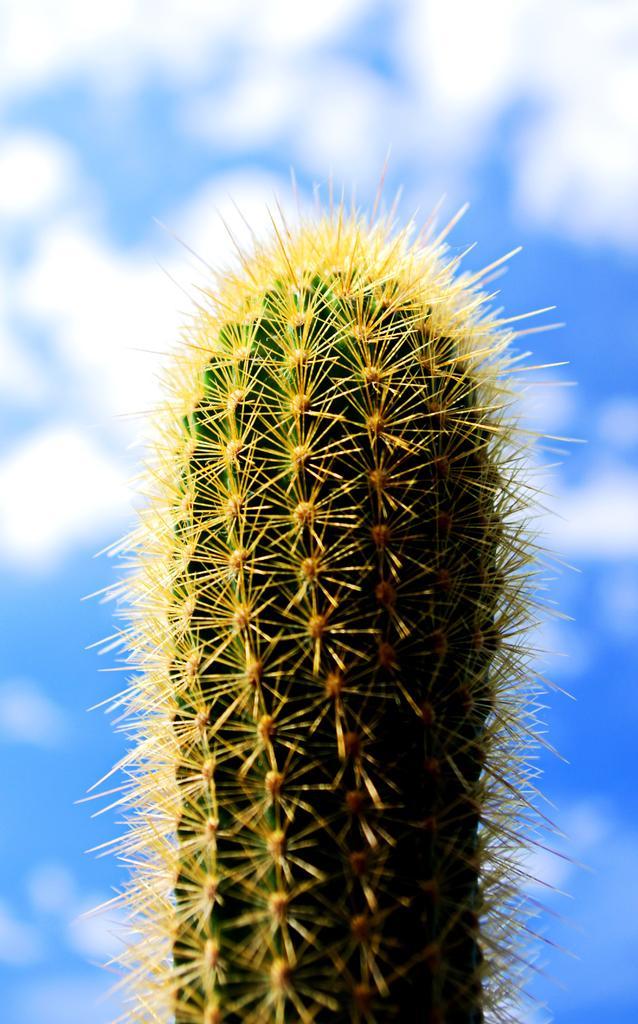Please provide a concise description of this image. In the picture I can see a cactus. The background of the image is blurred. 